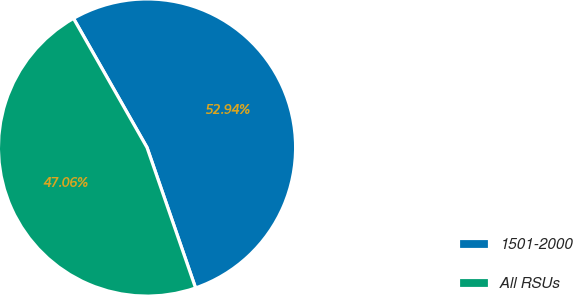Convert chart to OTSL. <chart><loc_0><loc_0><loc_500><loc_500><pie_chart><fcel>1501-2000<fcel>All RSUs<nl><fcel>52.94%<fcel>47.06%<nl></chart> 